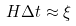<formula> <loc_0><loc_0><loc_500><loc_500>H \Delta t \approx { \xi }</formula> 